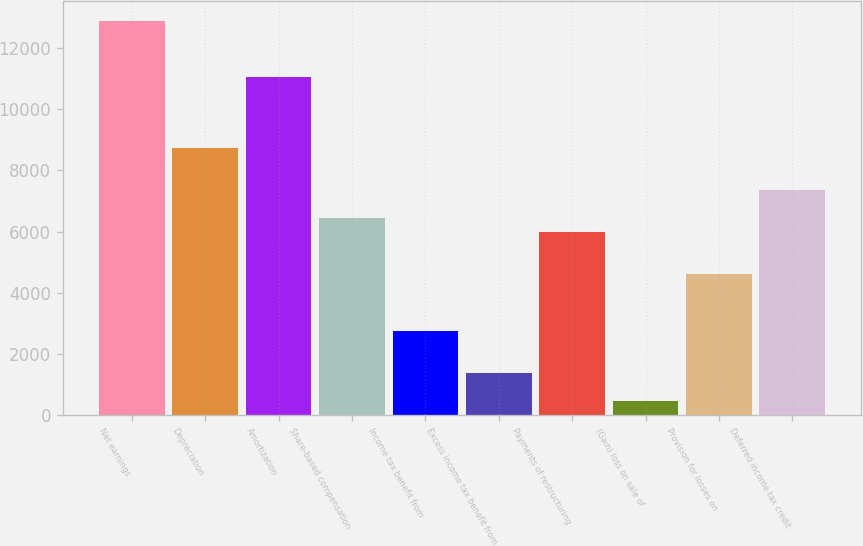Convert chart. <chart><loc_0><loc_0><loc_500><loc_500><bar_chart><fcel>Net earnings<fcel>Depreciation<fcel>Amortization<fcel>Share-based compensation<fcel>Income tax benefit from<fcel>Excess income tax benefit from<fcel>Payments of restructuring<fcel>(Gain) loss on sale of<fcel>Provision for losses on<fcel>Deferred income tax credit<nl><fcel>12883.2<fcel>8742.64<fcel>11042.9<fcel>6442.34<fcel>2761.86<fcel>1381.68<fcel>5982.28<fcel>461.56<fcel>4602.1<fcel>7362.46<nl></chart> 